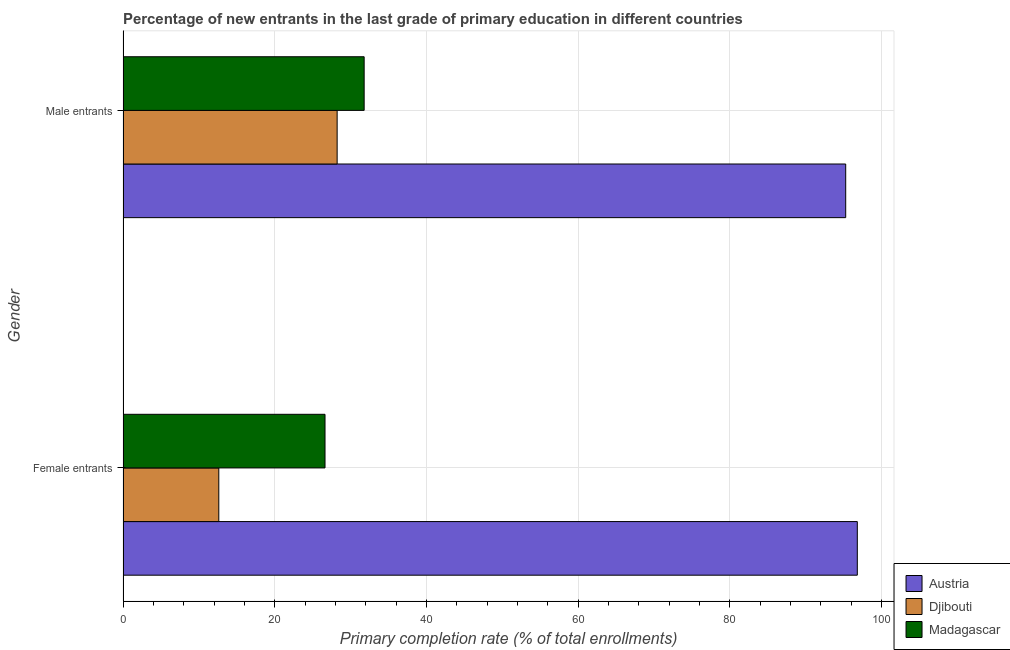How many bars are there on the 1st tick from the bottom?
Ensure brevity in your answer.  3. What is the label of the 2nd group of bars from the top?
Offer a very short reply. Female entrants. What is the primary completion rate of male entrants in Madagascar?
Provide a short and direct response. 31.8. Across all countries, what is the maximum primary completion rate of female entrants?
Your answer should be very brief. 96.82. Across all countries, what is the minimum primary completion rate of male entrants?
Make the answer very short. 28.24. In which country was the primary completion rate of female entrants maximum?
Keep it short and to the point. Austria. In which country was the primary completion rate of female entrants minimum?
Offer a terse response. Djibouti. What is the total primary completion rate of male entrants in the graph?
Your answer should be compact. 155.32. What is the difference between the primary completion rate of male entrants in Djibouti and that in Madagascar?
Your response must be concise. -3.56. What is the difference between the primary completion rate of female entrants in Austria and the primary completion rate of male entrants in Djibouti?
Your answer should be very brief. 68.59. What is the average primary completion rate of male entrants per country?
Your answer should be compact. 51.77. What is the difference between the primary completion rate of female entrants and primary completion rate of male entrants in Madagascar?
Offer a very short reply. -5.16. What is the ratio of the primary completion rate of female entrants in Madagascar to that in Djibouti?
Your answer should be very brief. 2.11. What does the 1st bar from the top in Female entrants represents?
Your answer should be compact. Madagascar. What does the 1st bar from the bottom in Female entrants represents?
Give a very brief answer. Austria. How many countries are there in the graph?
Your answer should be compact. 3. What is the difference between two consecutive major ticks on the X-axis?
Make the answer very short. 20. Are the values on the major ticks of X-axis written in scientific E-notation?
Make the answer very short. No. Does the graph contain grids?
Provide a succinct answer. Yes. How are the legend labels stacked?
Your answer should be very brief. Vertical. What is the title of the graph?
Offer a very short reply. Percentage of new entrants in the last grade of primary education in different countries. What is the label or title of the X-axis?
Ensure brevity in your answer.  Primary completion rate (% of total enrollments). What is the Primary completion rate (% of total enrollments) of Austria in Female entrants?
Keep it short and to the point. 96.82. What is the Primary completion rate (% of total enrollments) in Djibouti in Female entrants?
Your answer should be compact. 12.63. What is the Primary completion rate (% of total enrollments) in Madagascar in Female entrants?
Give a very brief answer. 26.64. What is the Primary completion rate (% of total enrollments) in Austria in Male entrants?
Offer a terse response. 95.29. What is the Primary completion rate (% of total enrollments) of Djibouti in Male entrants?
Your answer should be compact. 28.24. What is the Primary completion rate (% of total enrollments) of Madagascar in Male entrants?
Make the answer very short. 31.8. Across all Gender, what is the maximum Primary completion rate (% of total enrollments) in Austria?
Offer a terse response. 96.82. Across all Gender, what is the maximum Primary completion rate (% of total enrollments) of Djibouti?
Your answer should be compact. 28.24. Across all Gender, what is the maximum Primary completion rate (% of total enrollments) in Madagascar?
Ensure brevity in your answer.  31.8. Across all Gender, what is the minimum Primary completion rate (% of total enrollments) of Austria?
Provide a short and direct response. 95.29. Across all Gender, what is the minimum Primary completion rate (% of total enrollments) of Djibouti?
Offer a terse response. 12.63. Across all Gender, what is the minimum Primary completion rate (% of total enrollments) of Madagascar?
Your answer should be very brief. 26.64. What is the total Primary completion rate (% of total enrollments) of Austria in the graph?
Your answer should be very brief. 192.11. What is the total Primary completion rate (% of total enrollments) of Djibouti in the graph?
Offer a terse response. 40.87. What is the total Primary completion rate (% of total enrollments) in Madagascar in the graph?
Make the answer very short. 58.43. What is the difference between the Primary completion rate (% of total enrollments) in Austria in Female entrants and that in Male entrants?
Keep it short and to the point. 1.53. What is the difference between the Primary completion rate (% of total enrollments) in Djibouti in Female entrants and that in Male entrants?
Your answer should be compact. -15.6. What is the difference between the Primary completion rate (% of total enrollments) in Madagascar in Female entrants and that in Male entrants?
Make the answer very short. -5.16. What is the difference between the Primary completion rate (% of total enrollments) of Austria in Female entrants and the Primary completion rate (% of total enrollments) of Djibouti in Male entrants?
Your response must be concise. 68.59. What is the difference between the Primary completion rate (% of total enrollments) in Austria in Female entrants and the Primary completion rate (% of total enrollments) in Madagascar in Male entrants?
Provide a succinct answer. 65.02. What is the difference between the Primary completion rate (% of total enrollments) in Djibouti in Female entrants and the Primary completion rate (% of total enrollments) in Madagascar in Male entrants?
Your response must be concise. -19.17. What is the average Primary completion rate (% of total enrollments) in Austria per Gender?
Your answer should be very brief. 96.06. What is the average Primary completion rate (% of total enrollments) in Djibouti per Gender?
Make the answer very short. 20.43. What is the average Primary completion rate (% of total enrollments) of Madagascar per Gender?
Provide a short and direct response. 29.22. What is the difference between the Primary completion rate (% of total enrollments) in Austria and Primary completion rate (% of total enrollments) in Djibouti in Female entrants?
Offer a very short reply. 84.19. What is the difference between the Primary completion rate (% of total enrollments) in Austria and Primary completion rate (% of total enrollments) in Madagascar in Female entrants?
Your response must be concise. 70.18. What is the difference between the Primary completion rate (% of total enrollments) in Djibouti and Primary completion rate (% of total enrollments) in Madagascar in Female entrants?
Keep it short and to the point. -14.01. What is the difference between the Primary completion rate (% of total enrollments) in Austria and Primary completion rate (% of total enrollments) in Djibouti in Male entrants?
Provide a succinct answer. 67.06. What is the difference between the Primary completion rate (% of total enrollments) in Austria and Primary completion rate (% of total enrollments) in Madagascar in Male entrants?
Offer a very short reply. 63.49. What is the difference between the Primary completion rate (% of total enrollments) in Djibouti and Primary completion rate (% of total enrollments) in Madagascar in Male entrants?
Keep it short and to the point. -3.56. What is the ratio of the Primary completion rate (% of total enrollments) in Austria in Female entrants to that in Male entrants?
Keep it short and to the point. 1.02. What is the ratio of the Primary completion rate (% of total enrollments) in Djibouti in Female entrants to that in Male entrants?
Make the answer very short. 0.45. What is the ratio of the Primary completion rate (% of total enrollments) in Madagascar in Female entrants to that in Male entrants?
Keep it short and to the point. 0.84. What is the difference between the highest and the second highest Primary completion rate (% of total enrollments) in Austria?
Provide a short and direct response. 1.53. What is the difference between the highest and the second highest Primary completion rate (% of total enrollments) of Djibouti?
Ensure brevity in your answer.  15.6. What is the difference between the highest and the second highest Primary completion rate (% of total enrollments) in Madagascar?
Your response must be concise. 5.16. What is the difference between the highest and the lowest Primary completion rate (% of total enrollments) in Austria?
Provide a succinct answer. 1.53. What is the difference between the highest and the lowest Primary completion rate (% of total enrollments) of Djibouti?
Your answer should be compact. 15.6. What is the difference between the highest and the lowest Primary completion rate (% of total enrollments) in Madagascar?
Offer a very short reply. 5.16. 